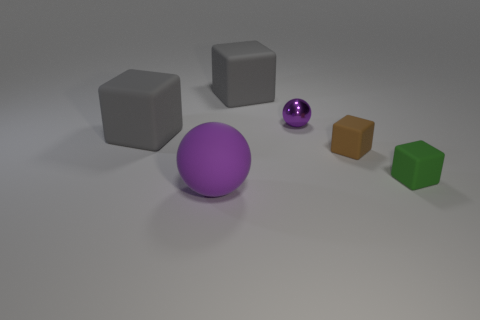Add 2 large gray cubes. How many objects exist? 8 Subtract all balls. How many objects are left? 4 Subtract all tiny cyan cubes. Subtract all small brown matte cubes. How many objects are left? 5 Add 6 small green rubber things. How many small green rubber things are left? 7 Add 6 big rubber objects. How many big rubber objects exist? 9 Subtract 0 purple cubes. How many objects are left? 6 